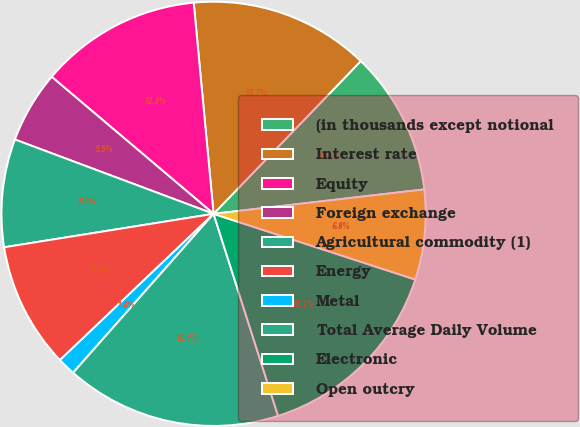<chart> <loc_0><loc_0><loc_500><loc_500><pie_chart><fcel>(in thousands except notional<fcel>Interest rate<fcel>Equity<fcel>Foreign exchange<fcel>Agricultural commodity (1)<fcel>Energy<fcel>Metal<fcel>Total Average Daily Volume<fcel>Electronic<fcel>Open outcry<nl><fcel>10.96%<fcel>13.7%<fcel>12.33%<fcel>5.48%<fcel>8.22%<fcel>9.59%<fcel>1.37%<fcel>16.44%<fcel>15.07%<fcel>6.85%<nl></chart> 